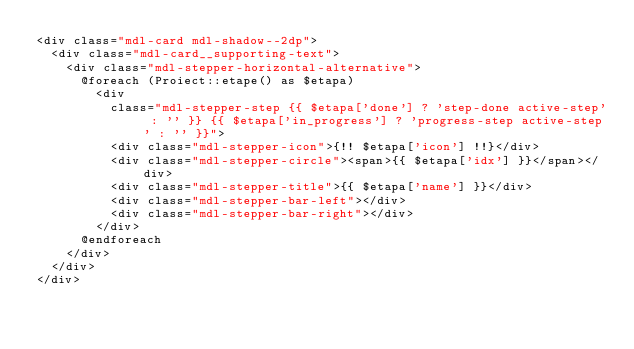<code> <loc_0><loc_0><loc_500><loc_500><_PHP_><div class="mdl-card mdl-shadow--2dp">
  <div class="mdl-card__supporting-text">
    <div class="mdl-stepper-horizontal-alternative">
      @foreach (Proiect::etape() as $etapa)
        <div
          class="mdl-stepper-step {{ $etapa['done'] ? 'step-done active-step' : '' }} {{ $etapa['in_progress'] ? 'progress-step active-step' : '' }}">
          <div class="mdl-stepper-icon">{!! $etapa['icon'] !!}</div>
          <div class="mdl-stepper-circle"><span>{{ $etapa['idx'] }}</span></div>
          <div class="mdl-stepper-title">{{ $etapa['name'] }}</div>
          <div class="mdl-stepper-bar-left"></div>
          <div class="mdl-stepper-bar-right"></div>
        </div>
      @endforeach
    </div>
  </div>
</div>
</code> 